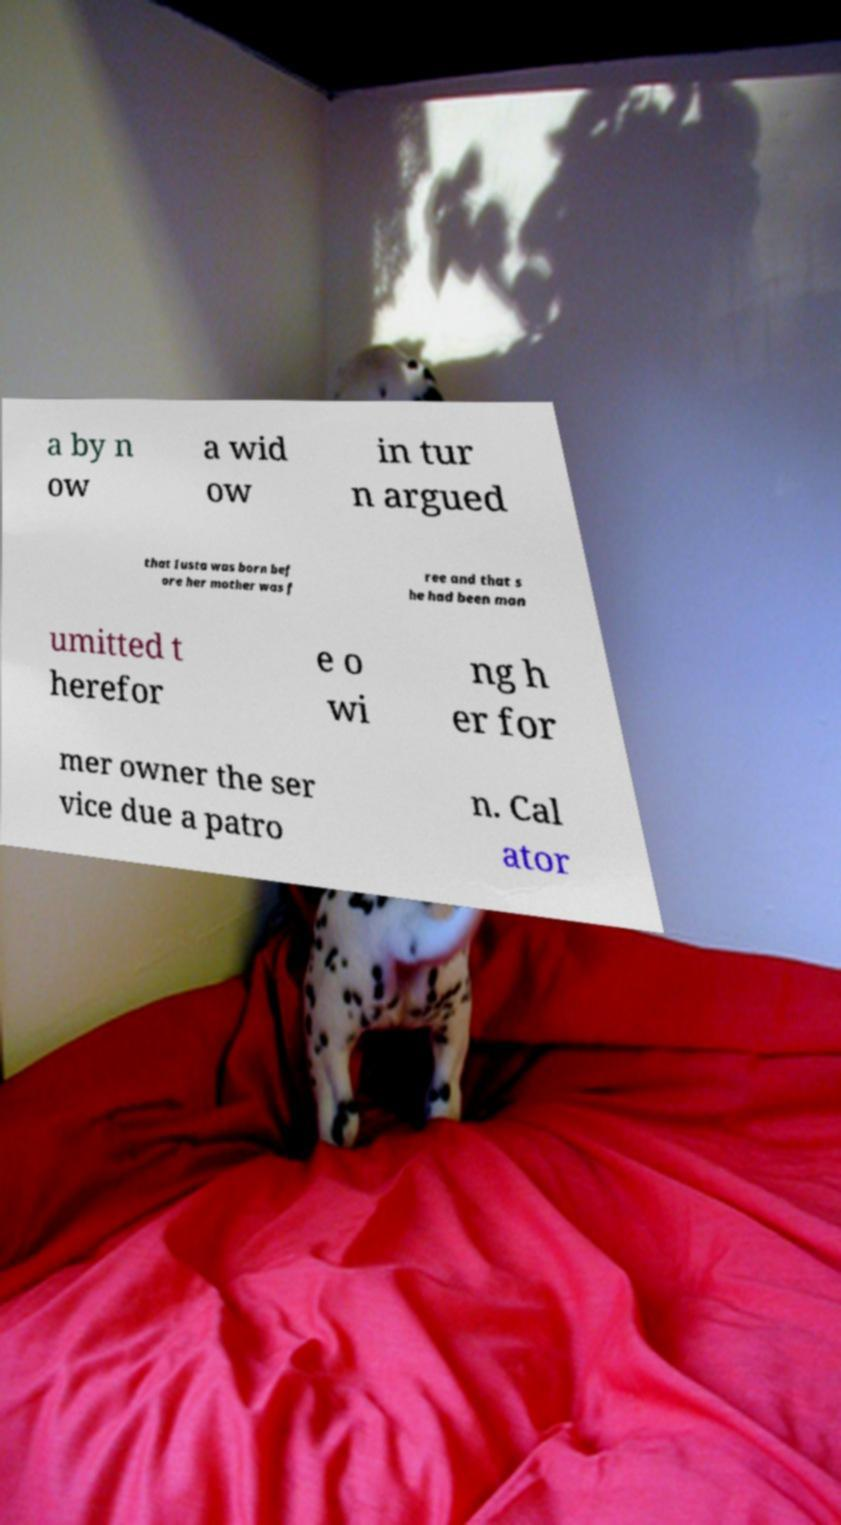I need the written content from this picture converted into text. Can you do that? a by n ow a wid ow in tur n argued that Iusta was born bef ore her mother was f ree and that s he had been man umitted t herefor e o wi ng h er for mer owner the ser vice due a patro n. Cal ator 